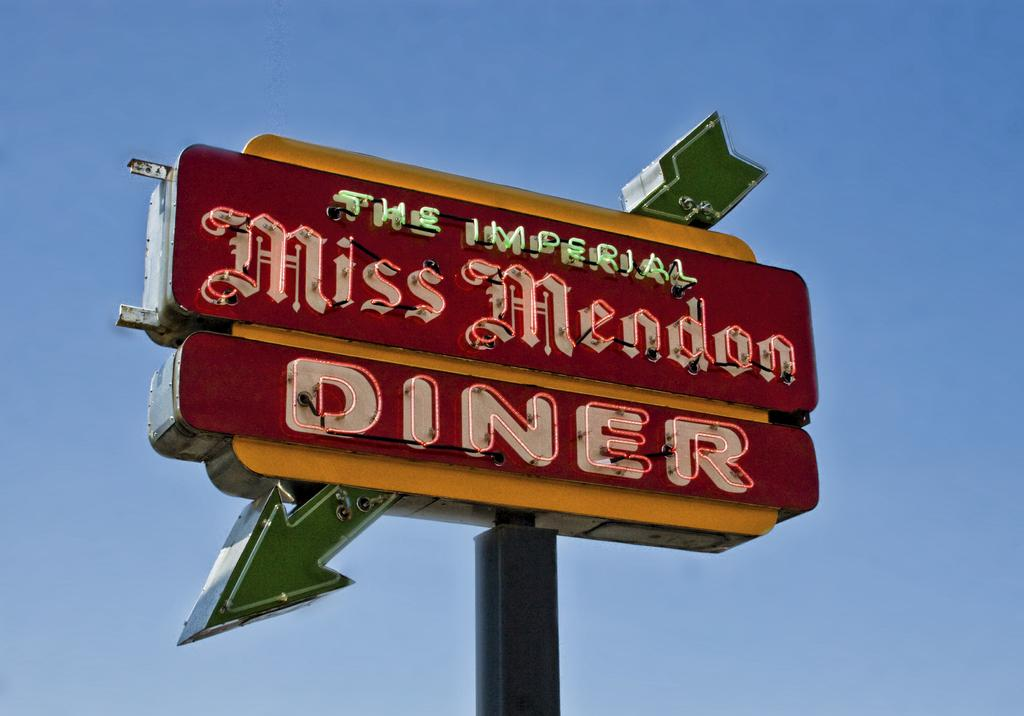<image>
Share a concise interpretation of the image provided. A red sign with a green arrow advertising The Imperial Miss Mendon Diner. 